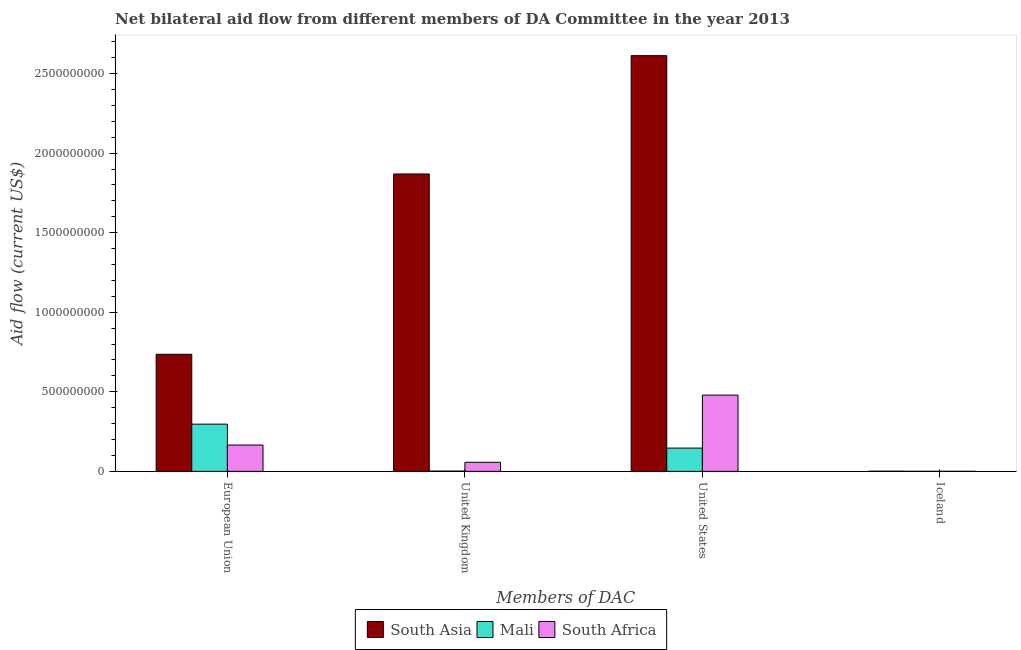Are the number of bars per tick equal to the number of legend labels?
Provide a short and direct response. Yes. How many bars are there on the 3rd tick from the left?
Your answer should be very brief. 3. How many bars are there on the 2nd tick from the right?
Your answer should be compact. 3. What is the amount of aid given by uk in Mali?
Offer a terse response. 1.61e+06. Across all countries, what is the maximum amount of aid given by uk?
Keep it short and to the point. 1.87e+09. Across all countries, what is the minimum amount of aid given by us?
Your response must be concise. 1.46e+08. In which country was the amount of aid given by us minimum?
Make the answer very short. Mali. What is the total amount of aid given by uk in the graph?
Keep it short and to the point. 1.93e+09. What is the difference between the amount of aid given by eu in Mali and that in South Asia?
Give a very brief answer. -4.39e+08. What is the difference between the amount of aid given by iceland in Mali and the amount of aid given by us in South Africa?
Ensure brevity in your answer.  -4.79e+08. What is the average amount of aid given by uk per country?
Offer a very short reply. 6.43e+08. What is the difference between the amount of aid given by iceland and amount of aid given by us in Mali?
Provide a short and direct response. -1.46e+08. What is the ratio of the amount of aid given by us in Mali to that in South Africa?
Your response must be concise. 0.31. Is the difference between the amount of aid given by uk in South Asia and Mali greater than the difference between the amount of aid given by eu in South Asia and Mali?
Your answer should be compact. Yes. What is the difference between the highest and the lowest amount of aid given by us?
Ensure brevity in your answer.  2.47e+09. In how many countries, is the amount of aid given by uk greater than the average amount of aid given by uk taken over all countries?
Your response must be concise. 1. Is it the case that in every country, the sum of the amount of aid given by uk and amount of aid given by iceland is greater than the sum of amount of aid given by eu and amount of aid given by us?
Keep it short and to the point. No. What does the 2nd bar from the left in United States represents?
Keep it short and to the point. Mali. What does the 2nd bar from the right in Iceland represents?
Your answer should be very brief. Mali. Is it the case that in every country, the sum of the amount of aid given by eu and amount of aid given by uk is greater than the amount of aid given by us?
Provide a short and direct response. No. How many countries are there in the graph?
Your answer should be compact. 3. What is the difference between two consecutive major ticks on the Y-axis?
Provide a succinct answer. 5.00e+08. Does the graph contain any zero values?
Make the answer very short. No. Does the graph contain grids?
Give a very brief answer. No. How many legend labels are there?
Offer a very short reply. 3. What is the title of the graph?
Offer a very short reply. Net bilateral aid flow from different members of DA Committee in the year 2013. Does "El Salvador" appear as one of the legend labels in the graph?
Offer a very short reply. No. What is the label or title of the X-axis?
Provide a short and direct response. Members of DAC. What is the Aid flow (current US$) in South Asia in European Union?
Offer a very short reply. 7.36e+08. What is the Aid flow (current US$) in Mali in European Union?
Give a very brief answer. 2.97e+08. What is the Aid flow (current US$) in South Africa in European Union?
Give a very brief answer. 1.65e+08. What is the Aid flow (current US$) in South Asia in United Kingdom?
Make the answer very short. 1.87e+09. What is the Aid flow (current US$) of Mali in United Kingdom?
Keep it short and to the point. 1.61e+06. What is the Aid flow (current US$) of South Africa in United Kingdom?
Give a very brief answer. 5.70e+07. What is the Aid flow (current US$) in South Asia in United States?
Your answer should be compact. 2.61e+09. What is the Aid flow (current US$) in Mali in United States?
Provide a succinct answer. 1.46e+08. What is the Aid flow (current US$) of South Africa in United States?
Offer a terse response. 4.79e+08. What is the Aid flow (current US$) of South Asia in Iceland?
Offer a terse response. 9.10e+05. Across all Members of DAC, what is the maximum Aid flow (current US$) of South Asia?
Ensure brevity in your answer.  2.61e+09. Across all Members of DAC, what is the maximum Aid flow (current US$) in Mali?
Ensure brevity in your answer.  2.97e+08. Across all Members of DAC, what is the maximum Aid flow (current US$) of South Africa?
Your answer should be compact. 4.79e+08. Across all Members of DAC, what is the minimum Aid flow (current US$) in South Asia?
Give a very brief answer. 9.10e+05. What is the total Aid flow (current US$) of South Asia in the graph?
Your answer should be compact. 5.22e+09. What is the total Aid flow (current US$) of Mali in the graph?
Provide a succinct answer. 4.45e+08. What is the total Aid flow (current US$) of South Africa in the graph?
Give a very brief answer. 7.02e+08. What is the difference between the Aid flow (current US$) of South Asia in European Union and that in United Kingdom?
Your answer should be compact. -1.13e+09. What is the difference between the Aid flow (current US$) of Mali in European Union and that in United Kingdom?
Give a very brief answer. 2.95e+08. What is the difference between the Aid flow (current US$) in South Africa in European Union and that in United Kingdom?
Your answer should be compact. 1.08e+08. What is the difference between the Aid flow (current US$) of South Asia in European Union and that in United States?
Offer a very short reply. -1.88e+09. What is the difference between the Aid flow (current US$) in Mali in European Union and that in United States?
Provide a succinct answer. 1.50e+08. What is the difference between the Aid flow (current US$) in South Africa in European Union and that in United States?
Provide a succinct answer. -3.14e+08. What is the difference between the Aid flow (current US$) in South Asia in European Union and that in Iceland?
Your response must be concise. 7.35e+08. What is the difference between the Aid flow (current US$) in Mali in European Union and that in Iceland?
Offer a very short reply. 2.97e+08. What is the difference between the Aid flow (current US$) of South Africa in European Union and that in Iceland?
Provide a short and direct response. 1.65e+08. What is the difference between the Aid flow (current US$) of South Asia in United Kingdom and that in United States?
Your answer should be very brief. -7.44e+08. What is the difference between the Aid flow (current US$) of Mali in United Kingdom and that in United States?
Offer a terse response. -1.45e+08. What is the difference between the Aid flow (current US$) of South Africa in United Kingdom and that in United States?
Keep it short and to the point. -4.22e+08. What is the difference between the Aid flow (current US$) of South Asia in United Kingdom and that in Iceland?
Offer a terse response. 1.87e+09. What is the difference between the Aid flow (current US$) in Mali in United Kingdom and that in Iceland?
Your response must be concise. 1.51e+06. What is the difference between the Aid flow (current US$) of South Africa in United Kingdom and that in Iceland?
Ensure brevity in your answer.  5.69e+07. What is the difference between the Aid flow (current US$) of South Asia in United States and that in Iceland?
Keep it short and to the point. 2.61e+09. What is the difference between the Aid flow (current US$) of Mali in United States and that in Iceland?
Ensure brevity in your answer.  1.46e+08. What is the difference between the Aid flow (current US$) of South Africa in United States and that in Iceland?
Your answer should be compact. 4.79e+08. What is the difference between the Aid flow (current US$) in South Asia in European Union and the Aid flow (current US$) in Mali in United Kingdom?
Offer a very short reply. 7.34e+08. What is the difference between the Aid flow (current US$) of South Asia in European Union and the Aid flow (current US$) of South Africa in United Kingdom?
Offer a terse response. 6.79e+08. What is the difference between the Aid flow (current US$) of Mali in European Union and the Aid flow (current US$) of South Africa in United Kingdom?
Ensure brevity in your answer.  2.40e+08. What is the difference between the Aid flow (current US$) of South Asia in European Union and the Aid flow (current US$) of Mali in United States?
Offer a terse response. 5.90e+08. What is the difference between the Aid flow (current US$) of South Asia in European Union and the Aid flow (current US$) of South Africa in United States?
Your answer should be very brief. 2.56e+08. What is the difference between the Aid flow (current US$) of Mali in European Union and the Aid flow (current US$) of South Africa in United States?
Ensure brevity in your answer.  -1.83e+08. What is the difference between the Aid flow (current US$) of South Asia in European Union and the Aid flow (current US$) of Mali in Iceland?
Provide a short and direct response. 7.36e+08. What is the difference between the Aid flow (current US$) in South Asia in European Union and the Aid flow (current US$) in South Africa in Iceland?
Provide a short and direct response. 7.36e+08. What is the difference between the Aid flow (current US$) in Mali in European Union and the Aid flow (current US$) in South Africa in Iceland?
Your answer should be compact. 2.97e+08. What is the difference between the Aid flow (current US$) in South Asia in United Kingdom and the Aid flow (current US$) in Mali in United States?
Your answer should be very brief. 1.72e+09. What is the difference between the Aid flow (current US$) in South Asia in United Kingdom and the Aid flow (current US$) in South Africa in United States?
Keep it short and to the point. 1.39e+09. What is the difference between the Aid flow (current US$) of Mali in United Kingdom and the Aid flow (current US$) of South Africa in United States?
Offer a very short reply. -4.78e+08. What is the difference between the Aid flow (current US$) of South Asia in United Kingdom and the Aid flow (current US$) of Mali in Iceland?
Offer a very short reply. 1.87e+09. What is the difference between the Aid flow (current US$) in South Asia in United Kingdom and the Aid flow (current US$) in South Africa in Iceland?
Keep it short and to the point. 1.87e+09. What is the difference between the Aid flow (current US$) in Mali in United Kingdom and the Aid flow (current US$) in South Africa in Iceland?
Provide a succinct answer. 1.50e+06. What is the difference between the Aid flow (current US$) in South Asia in United States and the Aid flow (current US$) in Mali in Iceland?
Offer a very short reply. 2.61e+09. What is the difference between the Aid flow (current US$) of South Asia in United States and the Aid flow (current US$) of South Africa in Iceland?
Offer a terse response. 2.61e+09. What is the difference between the Aid flow (current US$) of Mali in United States and the Aid flow (current US$) of South Africa in Iceland?
Keep it short and to the point. 1.46e+08. What is the average Aid flow (current US$) in South Asia per Members of DAC?
Ensure brevity in your answer.  1.30e+09. What is the average Aid flow (current US$) in Mali per Members of DAC?
Your answer should be very brief. 1.11e+08. What is the average Aid flow (current US$) in South Africa per Members of DAC?
Your answer should be very brief. 1.75e+08. What is the difference between the Aid flow (current US$) in South Asia and Aid flow (current US$) in Mali in European Union?
Make the answer very short. 4.39e+08. What is the difference between the Aid flow (current US$) in South Asia and Aid flow (current US$) in South Africa in European Union?
Make the answer very short. 5.70e+08. What is the difference between the Aid flow (current US$) in Mali and Aid flow (current US$) in South Africa in European Union?
Your answer should be very brief. 1.31e+08. What is the difference between the Aid flow (current US$) of South Asia and Aid flow (current US$) of Mali in United Kingdom?
Make the answer very short. 1.87e+09. What is the difference between the Aid flow (current US$) of South Asia and Aid flow (current US$) of South Africa in United Kingdom?
Ensure brevity in your answer.  1.81e+09. What is the difference between the Aid flow (current US$) in Mali and Aid flow (current US$) in South Africa in United Kingdom?
Provide a succinct answer. -5.54e+07. What is the difference between the Aid flow (current US$) of South Asia and Aid flow (current US$) of Mali in United States?
Your answer should be compact. 2.47e+09. What is the difference between the Aid flow (current US$) of South Asia and Aid flow (current US$) of South Africa in United States?
Provide a succinct answer. 2.13e+09. What is the difference between the Aid flow (current US$) of Mali and Aid flow (current US$) of South Africa in United States?
Your answer should be compact. -3.33e+08. What is the difference between the Aid flow (current US$) in South Asia and Aid flow (current US$) in Mali in Iceland?
Provide a short and direct response. 8.10e+05. What is the difference between the Aid flow (current US$) in Mali and Aid flow (current US$) in South Africa in Iceland?
Your response must be concise. -10000. What is the ratio of the Aid flow (current US$) in South Asia in European Union to that in United Kingdom?
Ensure brevity in your answer.  0.39. What is the ratio of the Aid flow (current US$) of Mali in European Union to that in United Kingdom?
Keep it short and to the point. 184.3. What is the ratio of the Aid flow (current US$) of South Africa in European Union to that in United Kingdom?
Ensure brevity in your answer.  2.9. What is the ratio of the Aid flow (current US$) in South Asia in European Union to that in United States?
Make the answer very short. 0.28. What is the ratio of the Aid flow (current US$) in Mali in European Union to that in United States?
Your answer should be compact. 2.03. What is the ratio of the Aid flow (current US$) of South Africa in European Union to that in United States?
Your response must be concise. 0.35. What is the ratio of the Aid flow (current US$) in South Asia in European Union to that in Iceland?
Give a very brief answer. 808.57. What is the ratio of the Aid flow (current US$) in Mali in European Union to that in Iceland?
Ensure brevity in your answer.  2967.2. What is the ratio of the Aid flow (current US$) of South Africa in European Union to that in Iceland?
Ensure brevity in your answer.  1504.09. What is the ratio of the Aid flow (current US$) in South Asia in United Kingdom to that in United States?
Make the answer very short. 0.72. What is the ratio of the Aid flow (current US$) of Mali in United Kingdom to that in United States?
Keep it short and to the point. 0.01. What is the ratio of the Aid flow (current US$) in South Africa in United Kingdom to that in United States?
Your answer should be compact. 0.12. What is the ratio of the Aid flow (current US$) in South Asia in United Kingdom to that in Iceland?
Offer a terse response. 2053.9. What is the ratio of the Aid flow (current US$) in Mali in United Kingdom to that in Iceland?
Your response must be concise. 16.1. What is the ratio of the Aid flow (current US$) in South Africa in United Kingdom to that in Iceland?
Keep it short and to the point. 518.18. What is the ratio of the Aid flow (current US$) of South Asia in United States to that in Iceland?
Provide a short and direct response. 2871. What is the ratio of the Aid flow (current US$) of Mali in United States to that in Iceland?
Ensure brevity in your answer.  1462.7. What is the ratio of the Aid flow (current US$) in South Africa in United States to that in Iceland?
Provide a succinct answer. 4357.73. What is the difference between the highest and the second highest Aid flow (current US$) in South Asia?
Keep it short and to the point. 7.44e+08. What is the difference between the highest and the second highest Aid flow (current US$) of Mali?
Provide a short and direct response. 1.50e+08. What is the difference between the highest and the second highest Aid flow (current US$) of South Africa?
Make the answer very short. 3.14e+08. What is the difference between the highest and the lowest Aid flow (current US$) in South Asia?
Keep it short and to the point. 2.61e+09. What is the difference between the highest and the lowest Aid flow (current US$) of Mali?
Provide a short and direct response. 2.97e+08. What is the difference between the highest and the lowest Aid flow (current US$) in South Africa?
Offer a very short reply. 4.79e+08. 